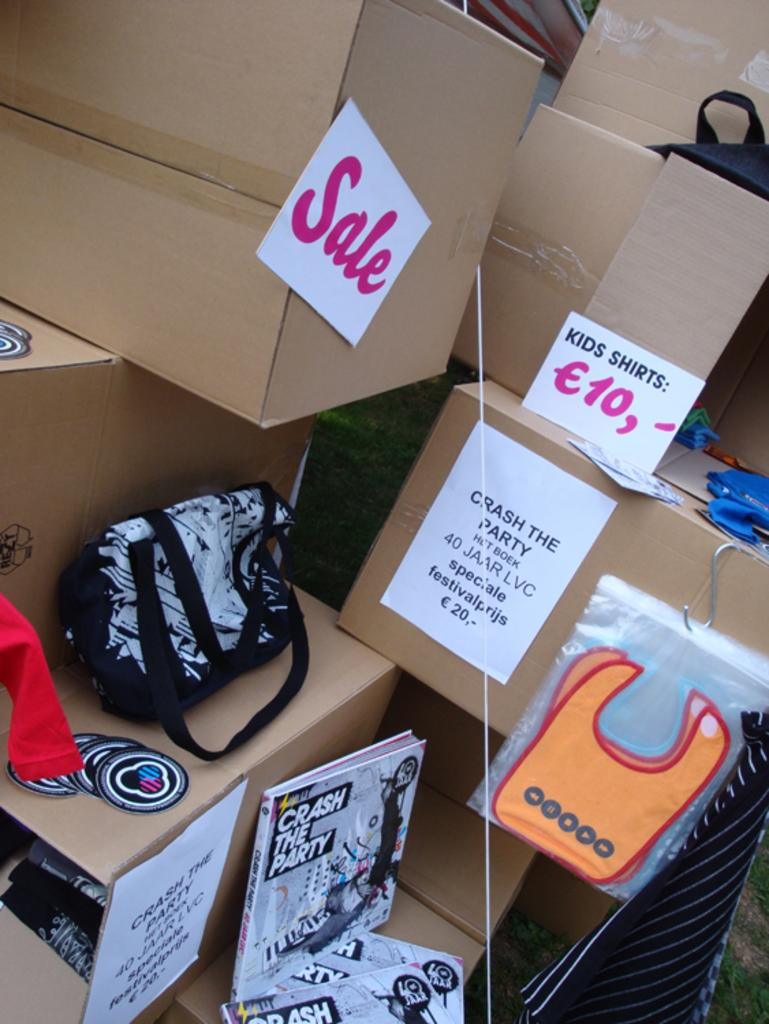<image>
Relay a brief, clear account of the picture shown. Many boxes are stacked in a pile with a Sale sign that advertises Kids Shirts and a book called Crash the Party. 